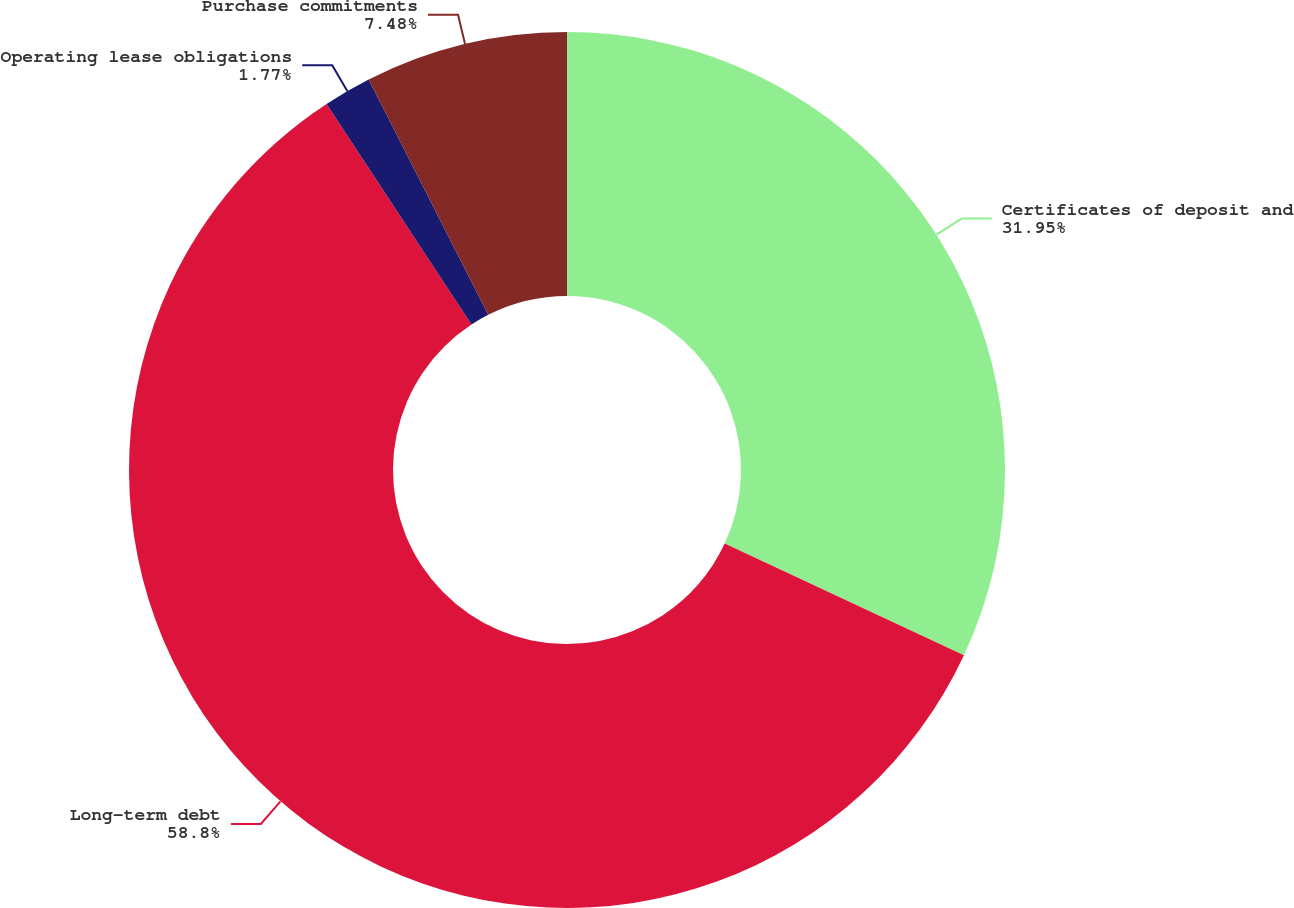Convert chart to OTSL. <chart><loc_0><loc_0><loc_500><loc_500><pie_chart><fcel>Certificates of deposit and<fcel>Long-term debt<fcel>Operating lease obligations<fcel>Purchase commitments<nl><fcel>31.95%<fcel>58.81%<fcel>1.77%<fcel>7.48%<nl></chart> 